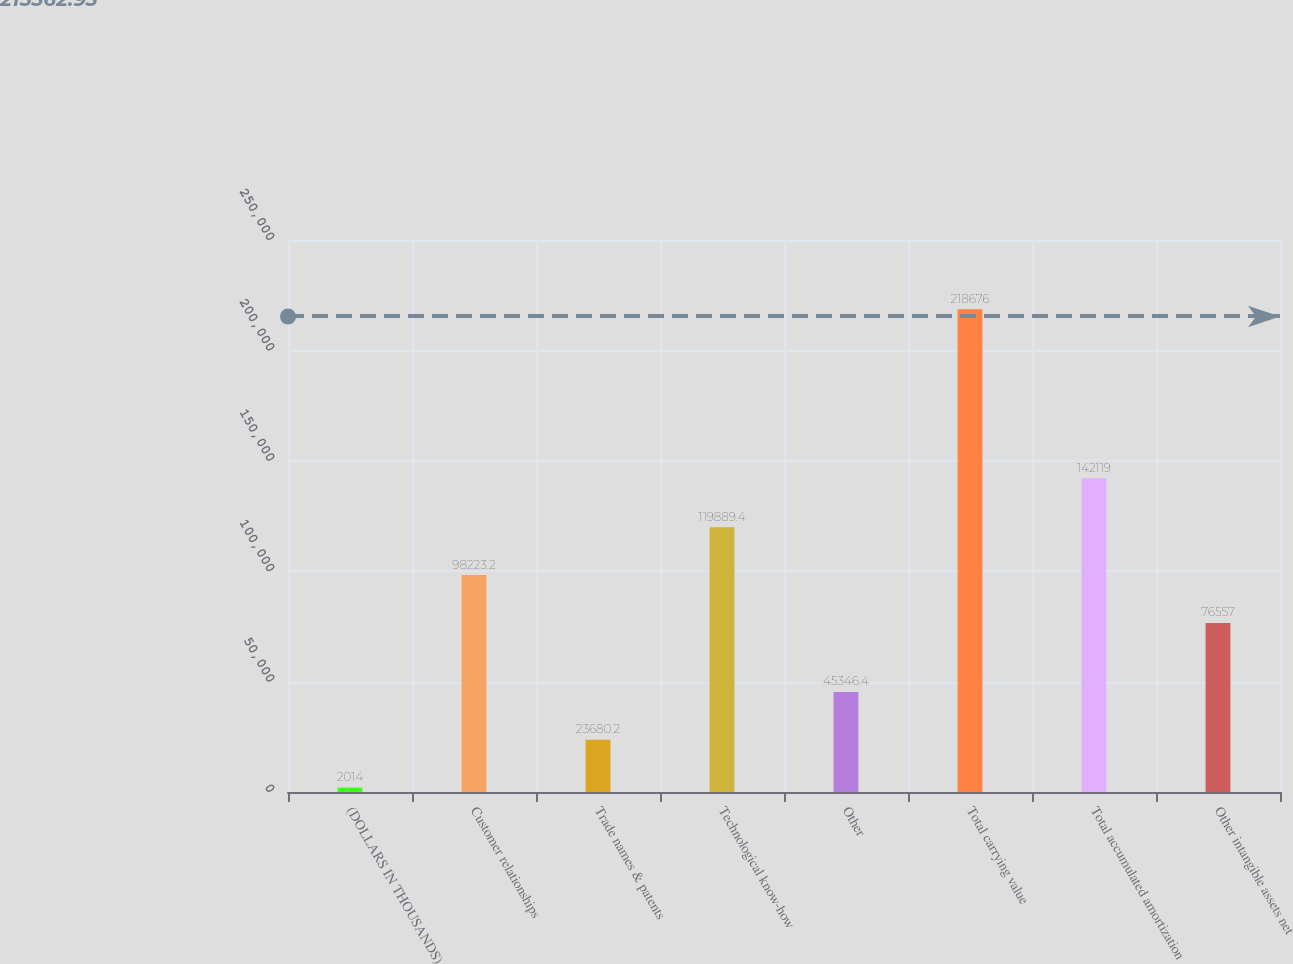<chart> <loc_0><loc_0><loc_500><loc_500><bar_chart><fcel>(DOLLARS IN THOUSANDS)<fcel>Customer relationships<fcel>Trade names & patents<fcel>Technological know-how<fcel>Other<fcel>Total carrying value<fcel>Total accumulated amortization<fcel>Other intangible assets net<nl><fcel>2014<fcel>98223.2<fcel>23680.2<fcel>119889<fcel>45346.4<fcel>218676<fcel>142119<fcel>76557<nl></chart> 